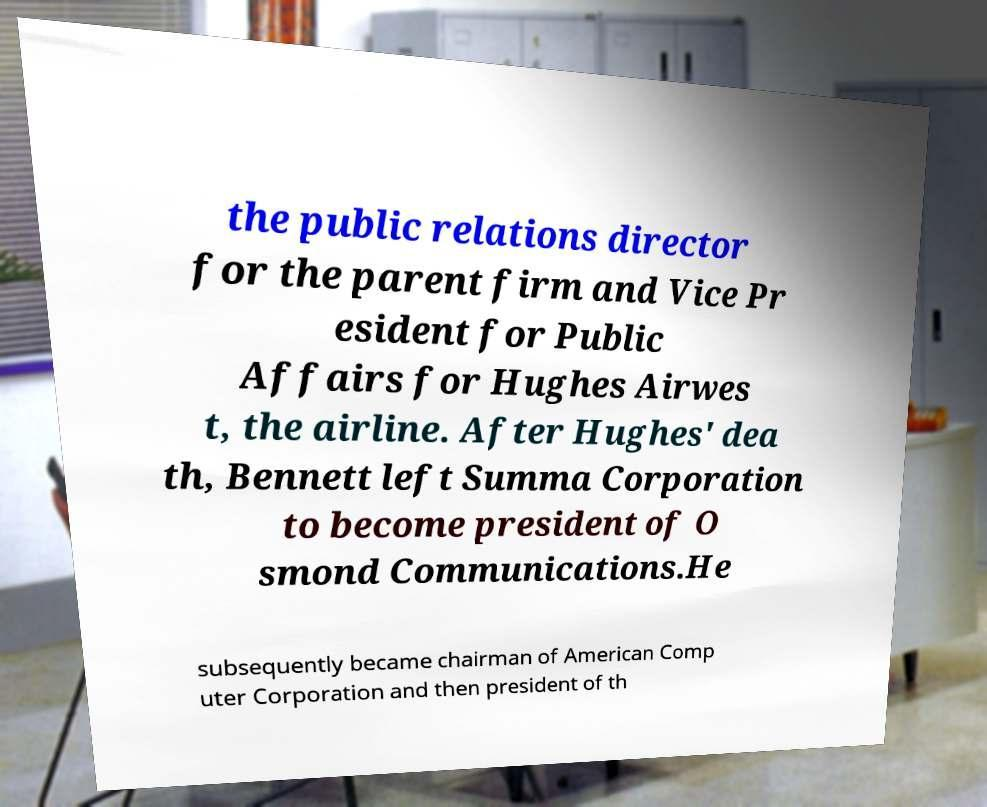Please read and relay the text visible in this image. What does it say? the public relations director for the parent firm and Vice Pr esident for Public Affairs for Hughes Airwes t, the airline. After Hughes' dea th, Bennett left Summa Corporation to become president of O smond Communications.He subsequently became chairman of American Comp uter Corporation and then president of th 